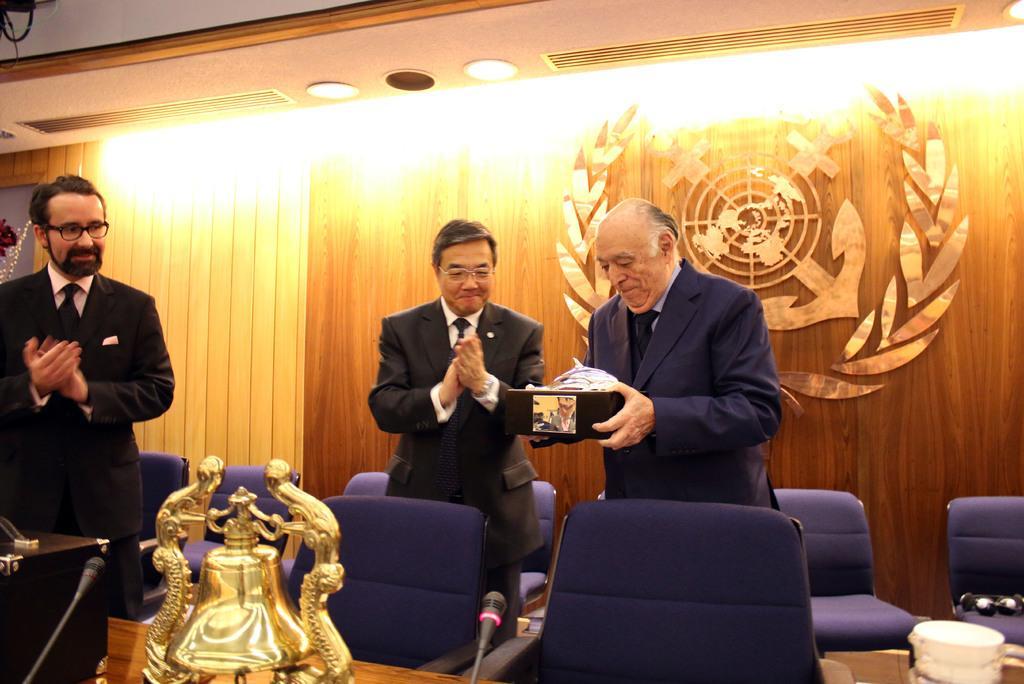Please provide a concise description of this image. In the image in the center we can see three persons were standing and they were smiling,which we can see on their faces. And the right side person is holding some object. And we can see few empty chairs,microphones,tables,wooden stand,glass and one yellow color object. In the background there is a wall,sign board,roof and lights. 